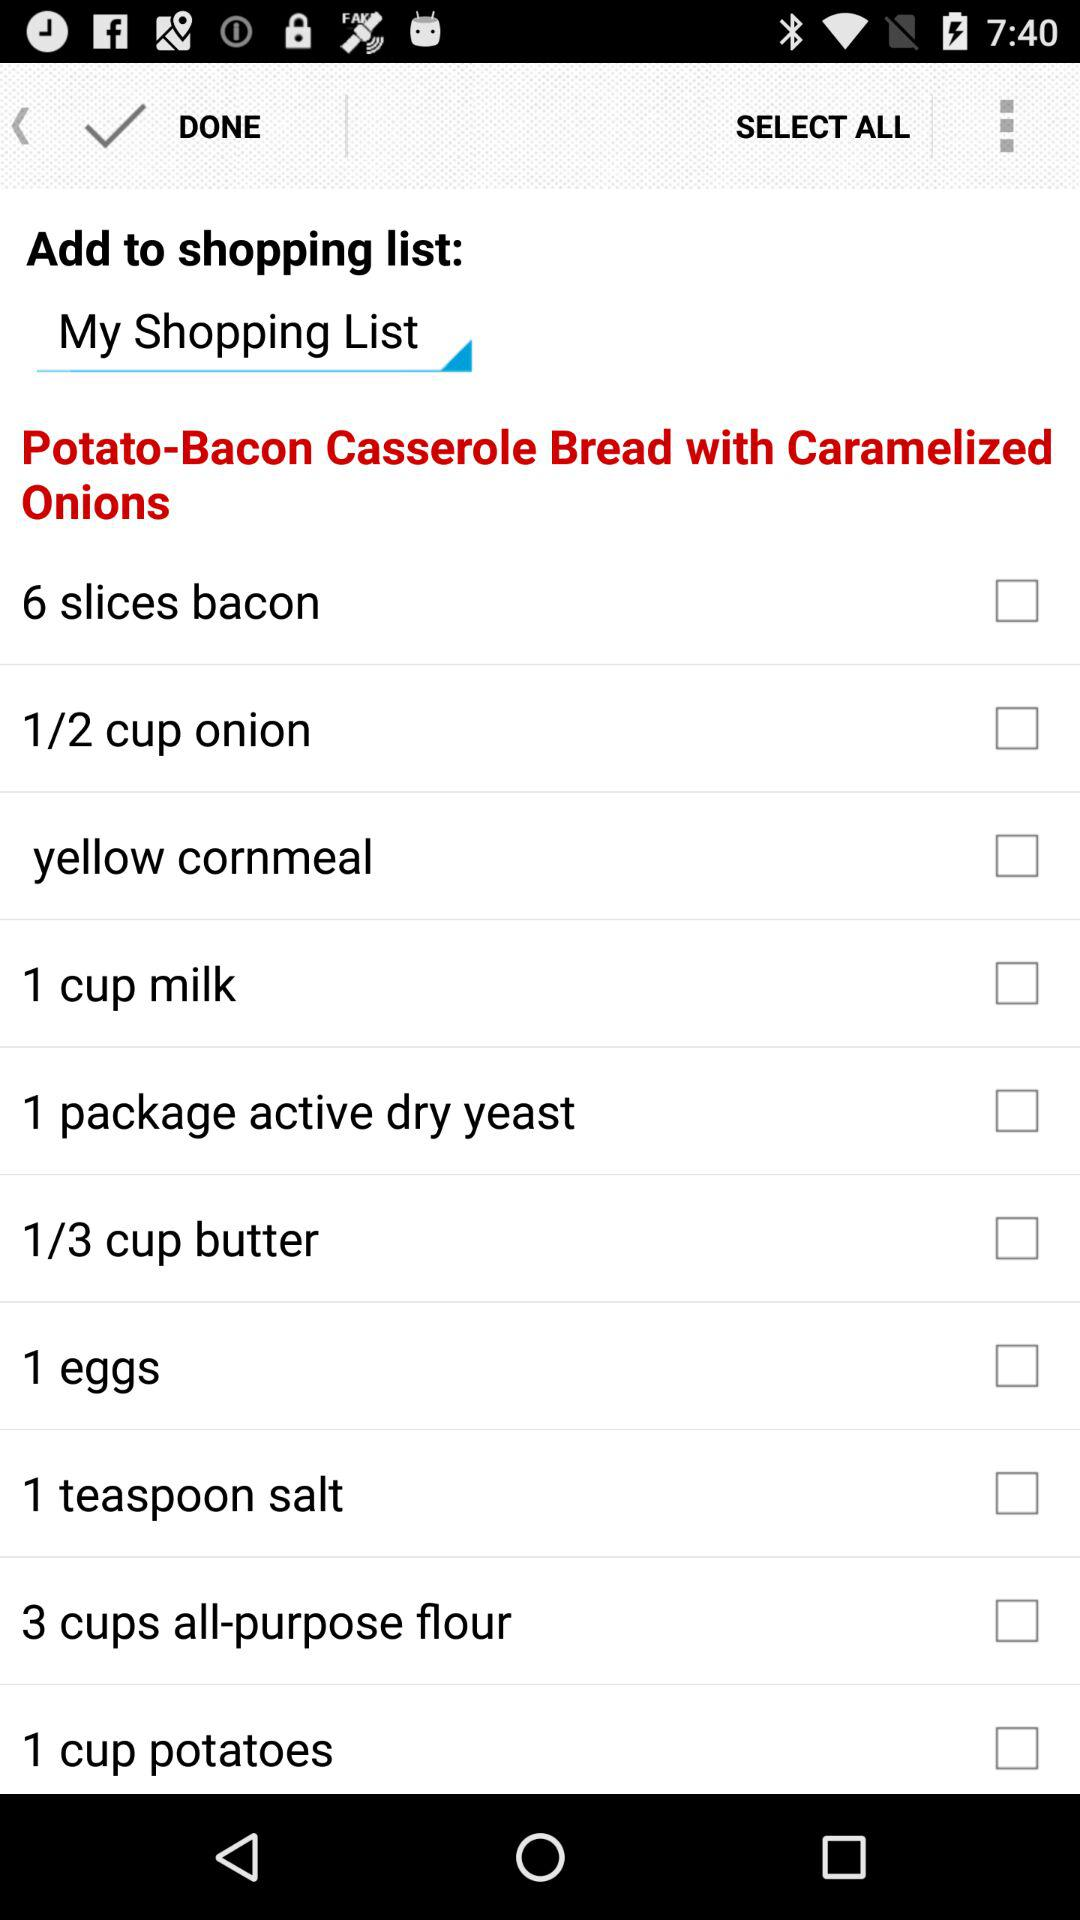How many calories are in "Potato-Bacon Casserole Bread with Caramelized Onions"?
When the provided information is insufficient, respond with <no answer>. <no answer> 